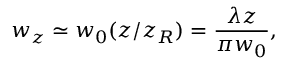Convert formula to latex. <formula><loc_0><loc_0><loc_500><loc_500>w _ { z } \simeq w _ { 0 } ( z / z _ { R } ) = \frac { \lambda z } { \pi w _ { 0 } } ,</formula> 